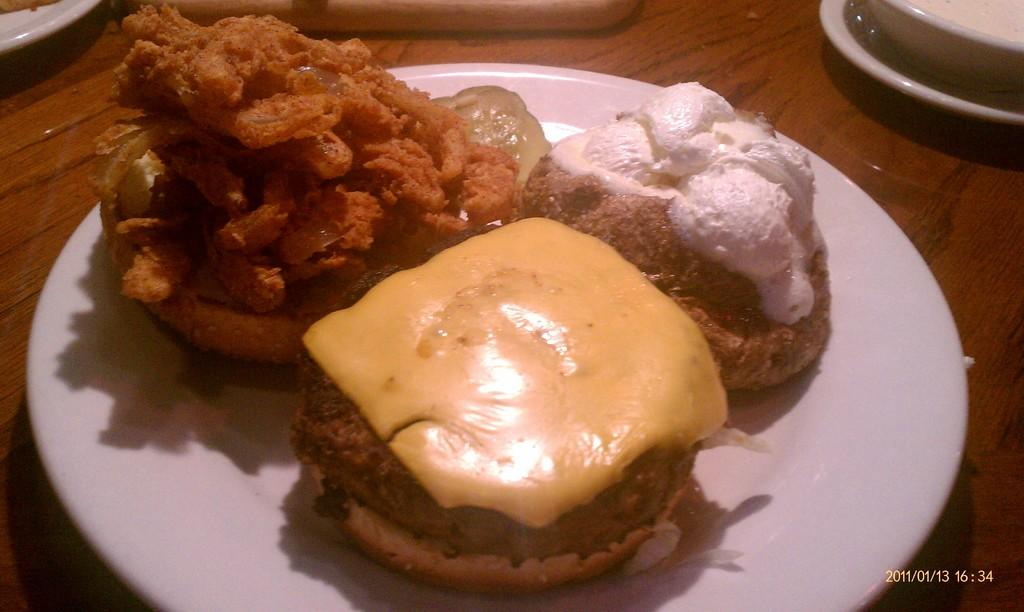What piece of furniture is present in the image? There is a table in the image. What is placed on the table? There is a plate on the table. What can be found on the plate? There is a food item on the plate. Can you provide any information about the date and time when the image was taken? The date and time are visible in the bottom right corner of the image. What type of education is being taught in the image? There is no indication of any educational activity in the image. 